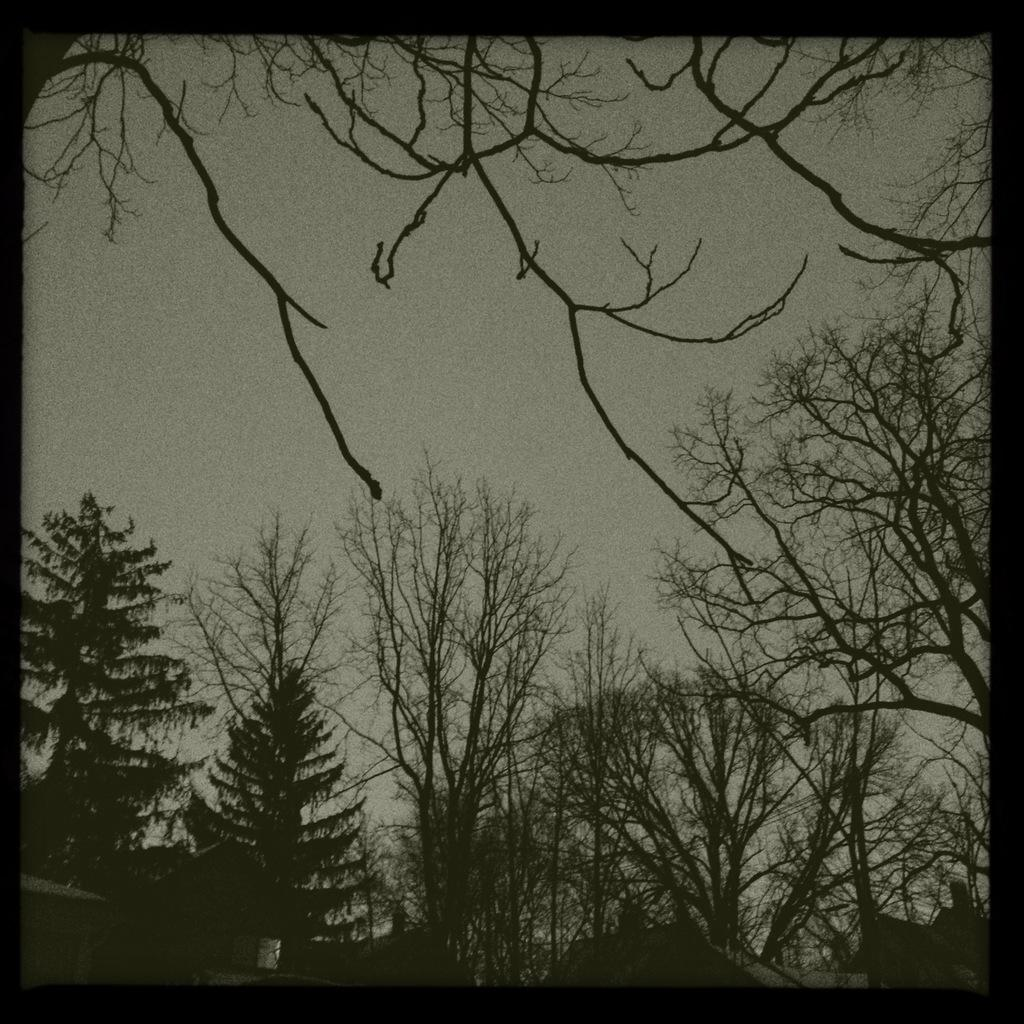What is the color scheme of the image? The image is black and white. What type of structures can be seen in the image? There are houses with roofs in the image. What type of vegetation is present in the image? There is a group of trees in the image. What is visible in the background of the image? The sky is visible in the image. What is the cause of the sea in the image? There is no sea present in the image; it only features houses, trees, and the sky. 